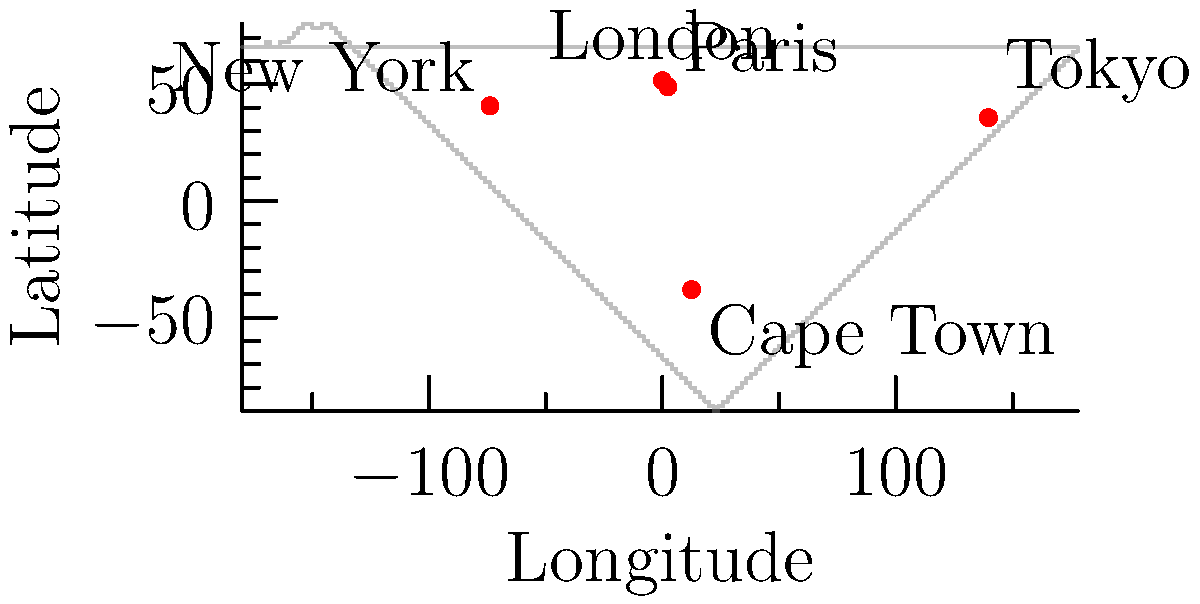As an independent film critic, you're planning to attend several international independent film festivals. Given the world map with five major independent film festival locations marked, which festival is located at approximately (139.7°E, 35.7°N)? To answer this question, we need to follow these steps:

1. Understand the coordinate system:
   - The first number represents longitude (East-West direction)
   - The second number represents latitude (North-South direction)
   - Positive longitude values indicate East, negative indicate West
   - Positive latitude values indicate North, negative indicate South

2. Identify the given coordinates: (139.7°E, 35.7°N)

3. Locate this point on the map:
   - Move 139.7° to the East (right) from the prime meridian (0°)
   - Move 35.7° to the North (up) from the equator (0°)

4. Check which festival location matches these coordinates:
   - London: (0°, 51.5°N) - Not a match
   - New York: (73.9°W, 40.7°N) - Not a match
   - Tokyo: (139.7°E, 35.7°N) - This matches the given coordinates
   - Paris: (2.3°E, 48.9°N) - Not a match
   - Cape Town: (12.5°E, 38.0°S) - Not a match

5. Conclude that the festival located at (139.7°E, 35.7°N) is in Tokyo.
Answer: Tokyo 